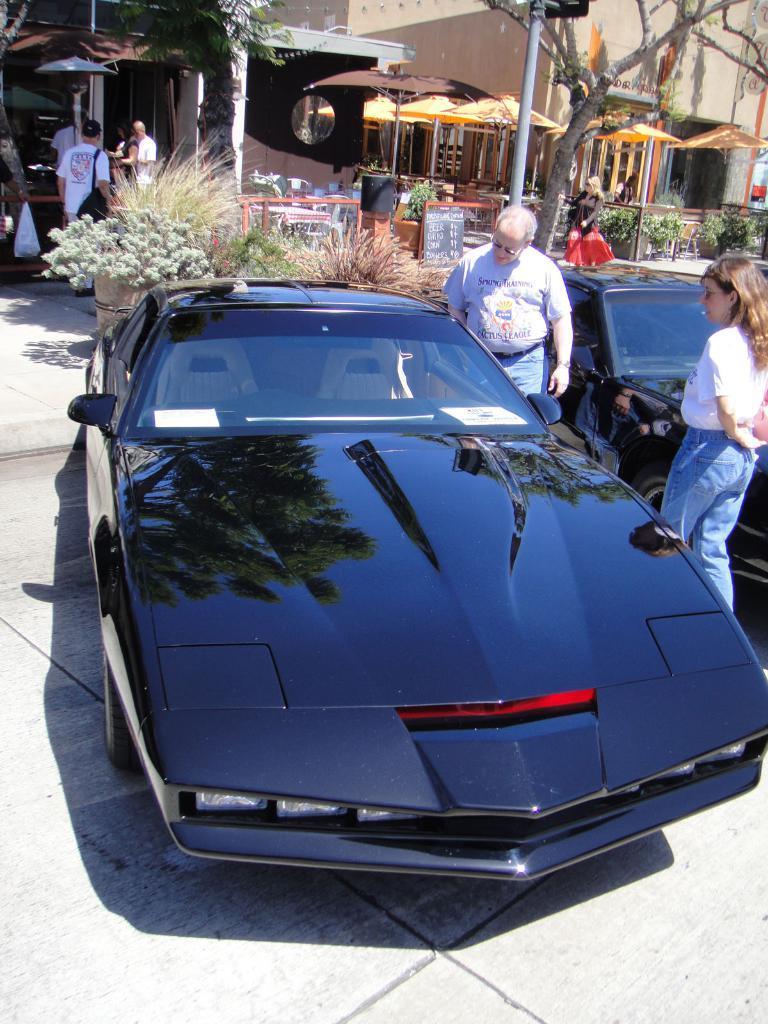In one or two sentences, can you explain what this image depicts? In the center of the image we can see persons at the car. On the right side of the image we can see person, building, tree, pole and car. In the background we can see buildings, tents, table, chairs and persons. 